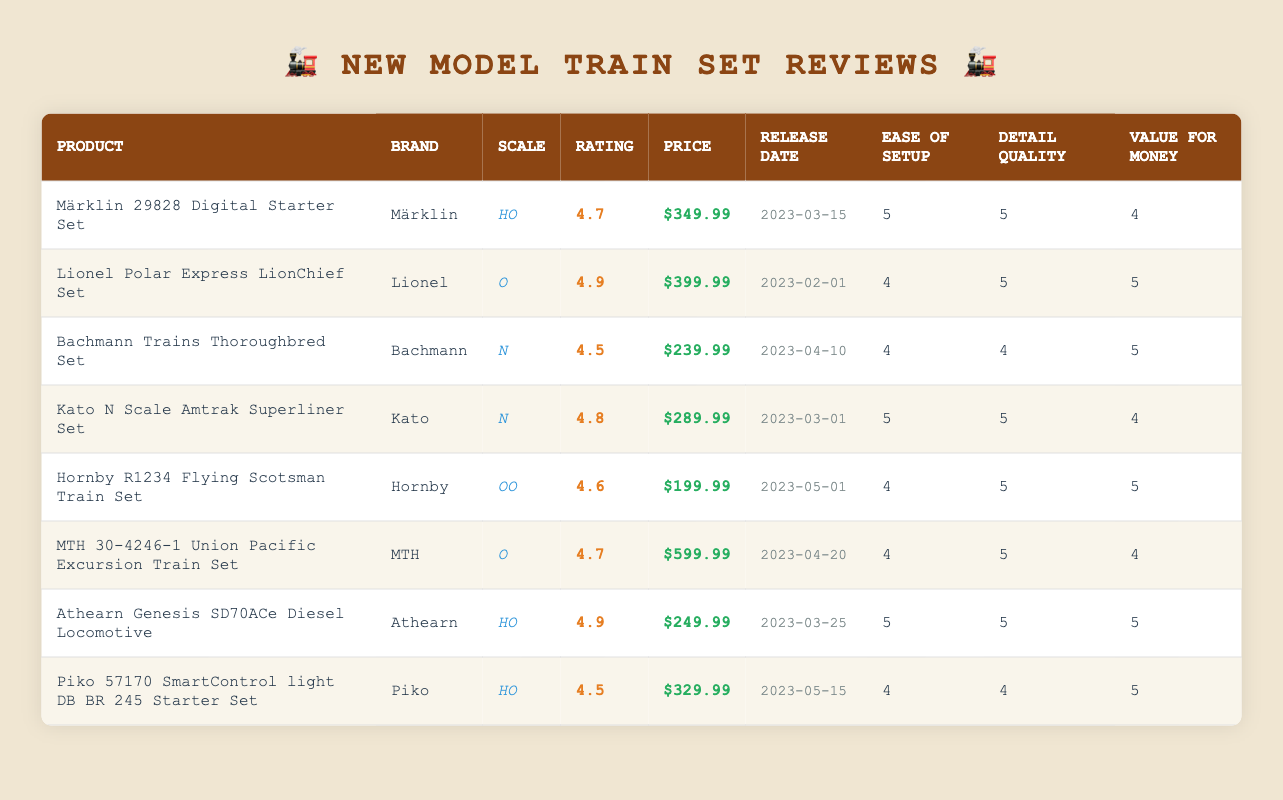What is the highest rating among the model train sets? The ratings of the model train sets are listed in the "Rating" column. The highest rating is 4.9, which appears for the Lionel Polar Express LionChief Set and the Athearn Genesis SD70ACe Diesel Locomotive.
Answer: 4.9 Which model train set has the lowest price? The prices of the model train sets are visible in the "Price" column. The lowest price is $199.99 for the Hornby R1234 Flying Scotsman Train Set.
Answer: $199.99 How many model train sets have a rating of 4.7 or higher? To answer this, I count the entries in the "Rating" column that are 4.7 or higher. There are 5 such entries: Märklin 29828 Digital Starter Set, Lionel Polar Express LionChief Set, Kato N Scale Amtrak Superliner Set, Athearn Genesis SD70ACe Diesel Locomotive, and MTH 30-4246-1 Union Pacific Excursion Train Set.
Answer: 5 What is the average price of model train sets rated 4.5 or higher? I first find the sets with a rating of 4.5 or higher: there are 6 of them. Their prices are $349.99, $399.99, $239.99, $289.99, $599.99, and $249.99. The total price is $2,109.94. Dividing this by 6 gives an average price of approximately $351.66.
Answer: $351.66 Is there any model train set that received a perfect score of 5 for all criteria? I check the "Ease of Setup," "Detail Quality," and "Value for Money" columns for scores of 5. The Athearn Genesis SD70ACe Diesel Locomotive received a score of 5 in all three categories, confirming it is the only set with perfect scores across the board.
Answer: Yes 